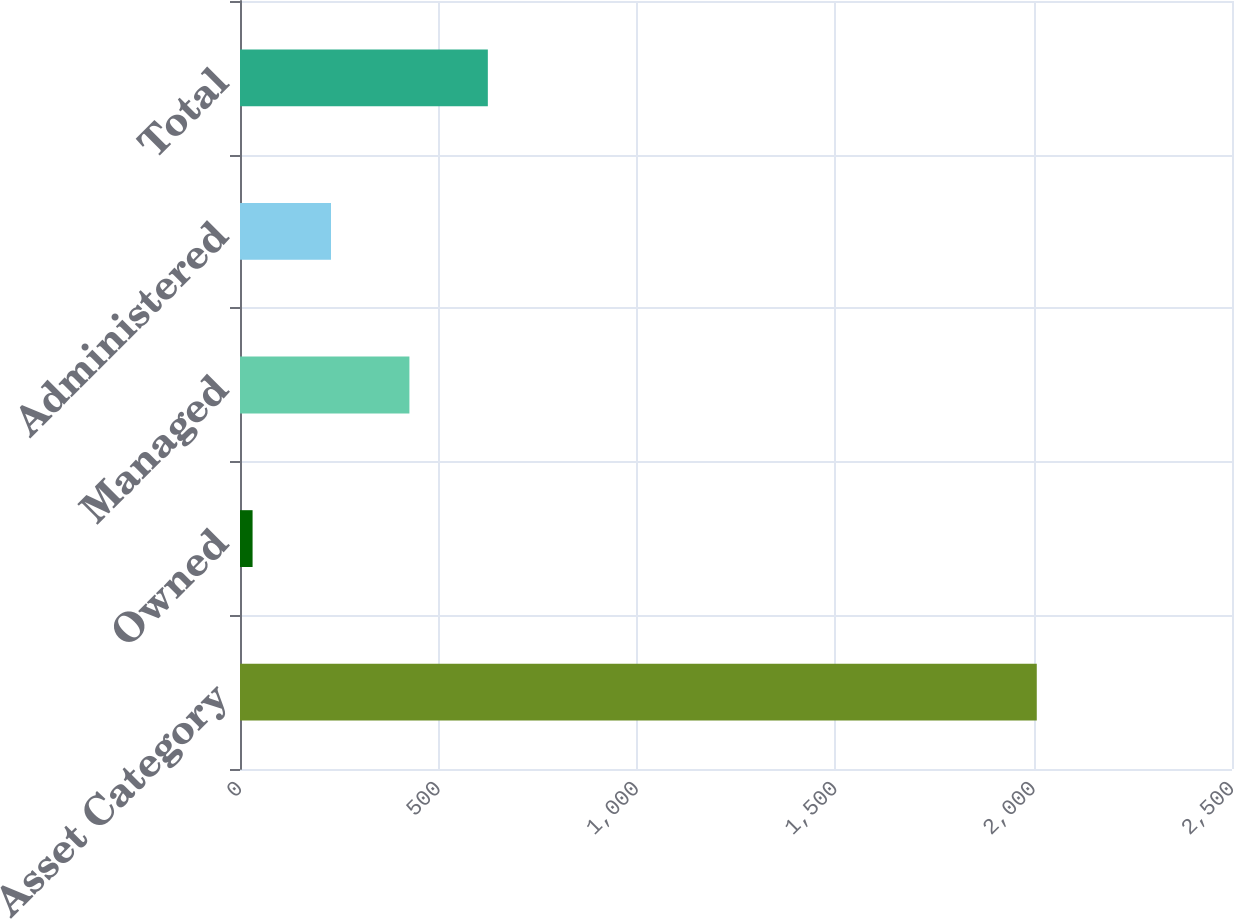<chart> <loc_0><loc_0><loc_500><loc_500><bar_chart><fcel>Asset Category<fcel>Owned<fcel>Managed<fcel>Administered<fcel>Total<nl><fcel>2008<fcel>31.7<fcel>426.96<fcel>229.33<fcel>624.59<nl></chart> 